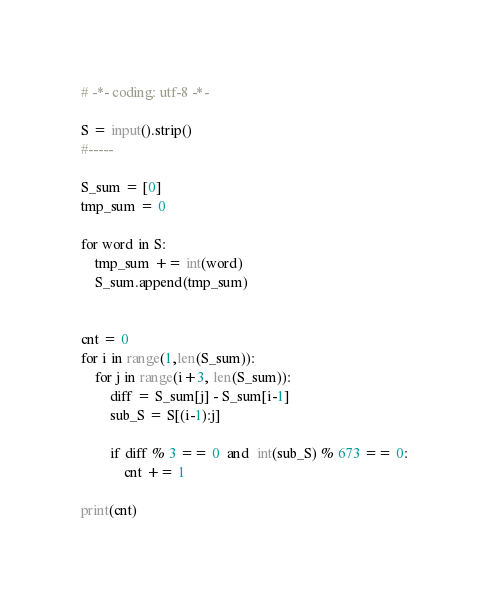Convert code to text. <code><loc_0><loc_0><loc_500><loc_500><_Python_># -*- coding: utf-8 -*-

S = input().strip()
#-----

S_sum = [0]
tmp_sum = 0

for word in S:
    tmp_sum += int(word)
    S_sum.append(tmp_sum)


cnt = 0
for i in range(1,len(S_sum)):
    for j in range(i+3, len(S_sum)):
        diff = S_sum[j] - S_sum[i-1]
        sub_S = S[(i-1):j]
        
        if diff % 3 == 0  and  int(sub_S) % 673 == 0:
            cnt += 1

print(cnt)
</code> 